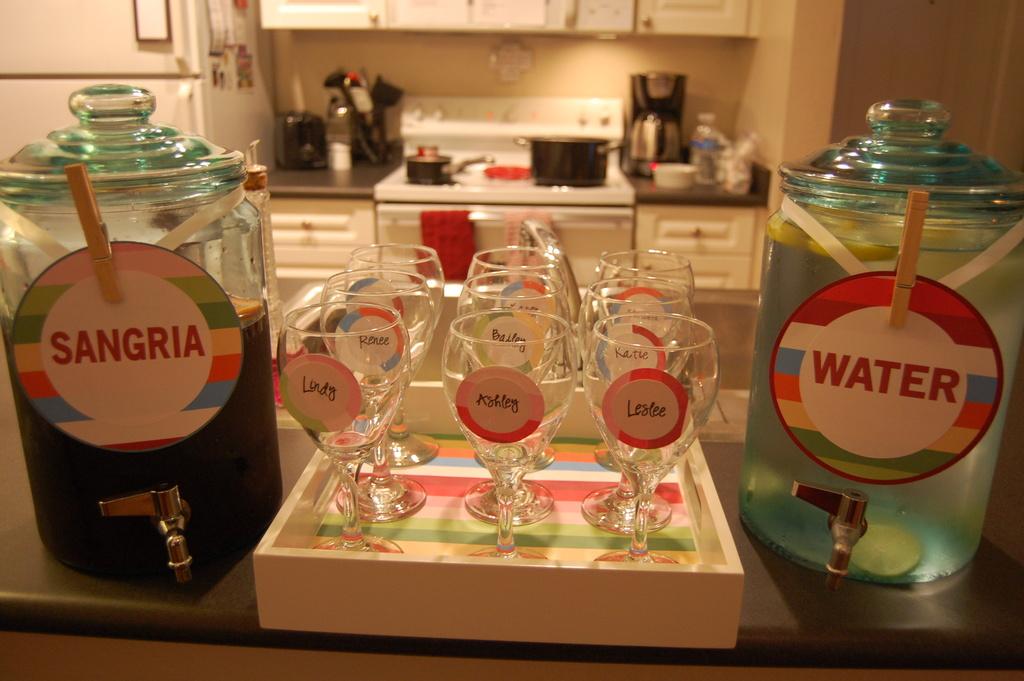What is in the right jug?
Ensure brevity in your answer.  Water. 